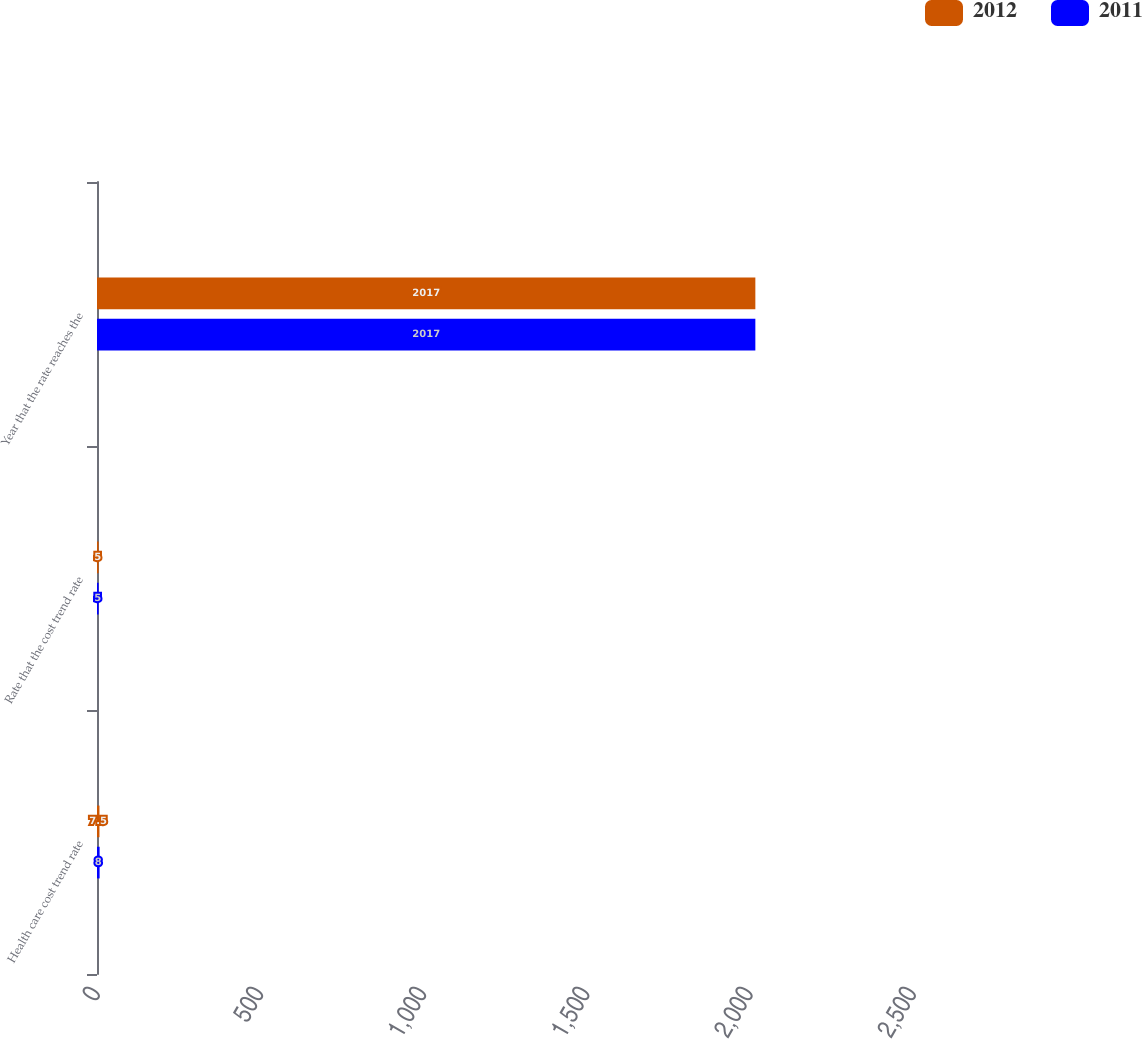Convert chart to OTSL. <chart><loc_0><loc_0><loc_500><loc_500><stacked_bar_chart><ecel><fcel>Health care cost trend rate<fcel>Rate that the cost trend rate<fcel>Year that the rate reaches the<nl><fcel>2012<fcel>7.5<fcel>5<fcel>2017<nl><fcel>2011<fcel>8<fcel>5<fcel>2017<nl></chart> 